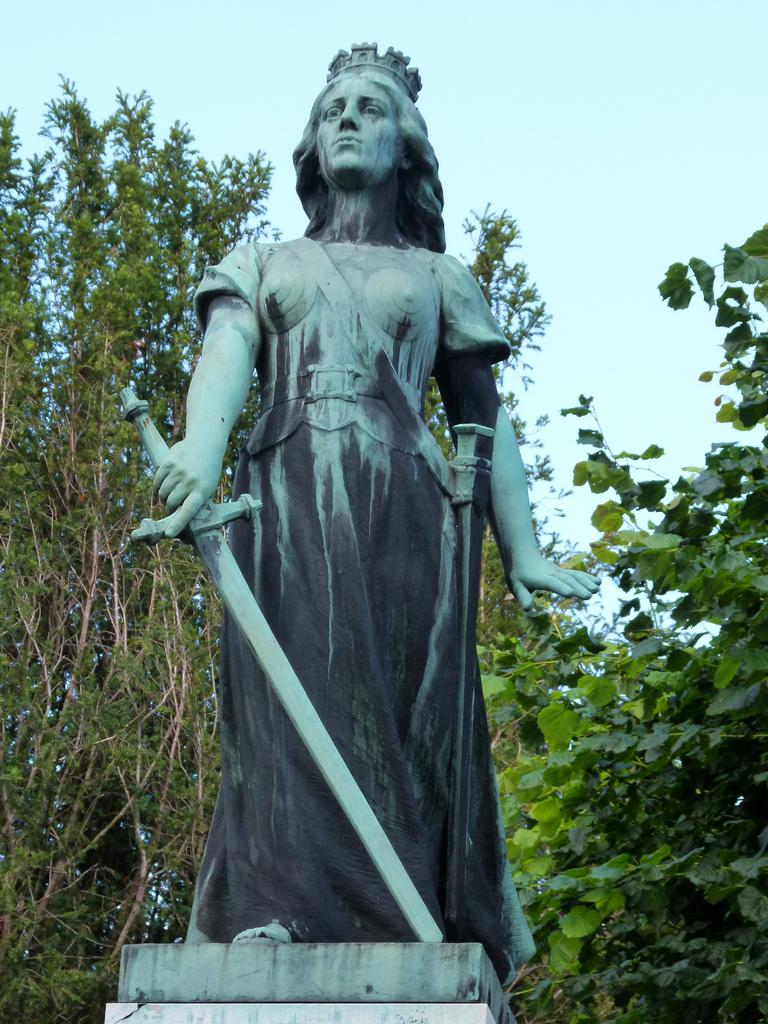What is the main subject of the image? There is a statue in the image. Can you describe the statue? The statue is in the shape of a woman. What can be seen in the background of the image? There are trees behind the statue. Where is the sofa located in the image? There is no sofa present in the image. How many snakes are wrapped around the statue in the image? There are no snakes present in the image; the statue is in the shape of a woman. 